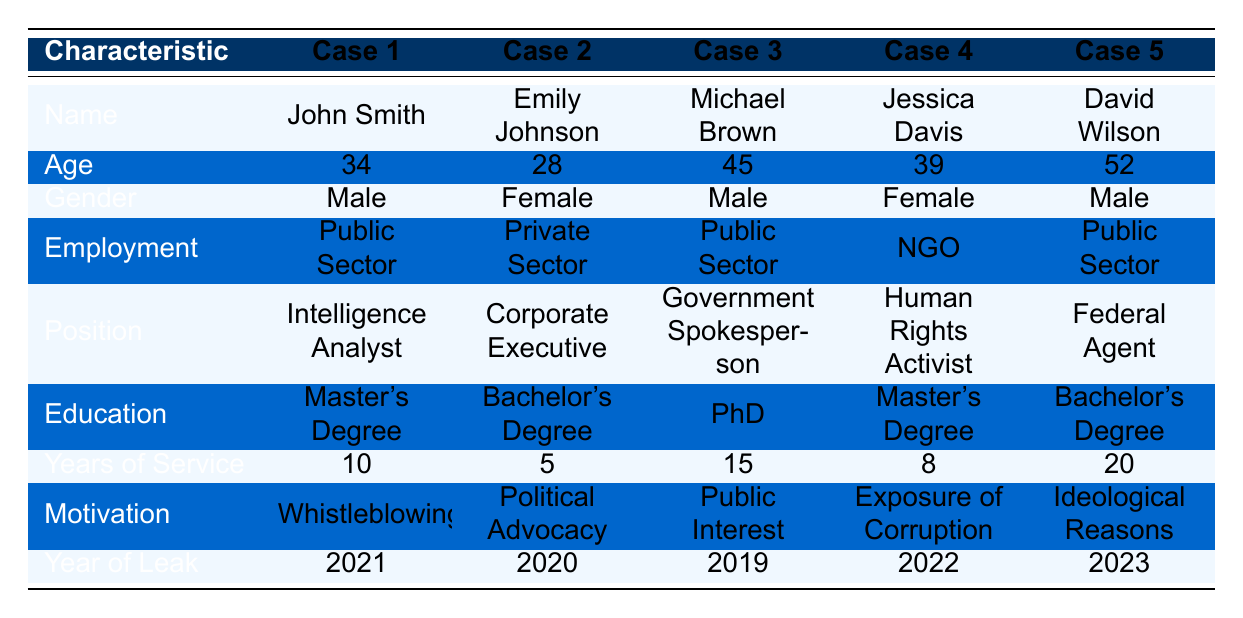What is the name of the individual involved in the case with the year of leak 2022? By scanning the table, we can see the year of leak for each case. The case with the year of leak 2022 corresponds to Jessica Davis.
Answer: Jessica Davis Which individual worked in the NGO sector? Referring to the employment status in the table, the person associated with the NGO is Jessica Davis.
Answer: Jessica Davis How many years of service did Michael Brown have? The table lists the years of service for each individual, and for Michael Brown, this value is 15 years.
Answer: 15 What is the average age of the individuals involved in these cases? To calculate the average age, sum the ages (34 + 28 + 45 + 39 + 52) = 198 and then divide by the number of individuals (5), so the average age is 198 / 5 = 39.6.
Answer: 39.6 Did any of the individuals leak information for political advocacy purposes? By checking the motivations listed, we see that Emily Johnson leaked information for political advocacy. Therefore, the answer is yes.
Answer: Yes Which individual has the highest years of service and what is that number? Looking through the years of service column for each individual, David Wilson has the highest years of service at 20 years.
Answer: David Wilson, 20 Is there any individual who has a PhD degree and what is their name? The table indicates that Michael Brown is the only individual with a PhD degree.
Answer: Michael Brown What is the total number of public sector employees involved in the cases? We count the rows where the employment status is public sector: John Smith, Michael Brown, and David Wilson, totaling 3 individuals.
Answer: 3 What is the difference in age between the oldest and youngest individuals in the cases? The oldest individual is David Wilson at 52 years, and the youngest is Emily Johnson at 28 years. The difference is 52 - 28 = 24 years.
Answer: 24 